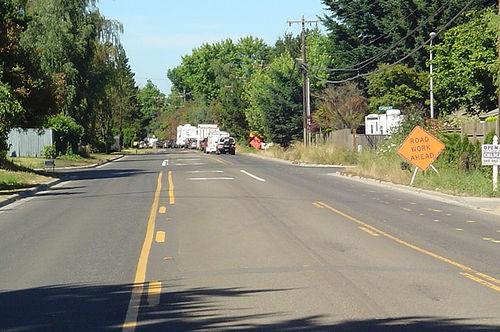Is the road busy?
Write a very short answer. No. Is there a truck on the road?
Give a very brief answer. Yes. What is this place?
Answer briefly. Road. Does there appear to be construction going on?
Quick response, please. Yes. 